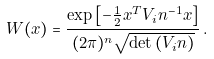<formula> <loc_0><loc_0><loc_500><loc_500>W ( x ) = \frac { \exp { \left [ - \frac { 1 } { 2 } x ^ { T } V _ { i } n ^ { - 1 } x \right ] } } { ( 2 \pi ) ^ { n } \sqrt { \det { ( V _ { i } n ) } } } \, .</formula> 